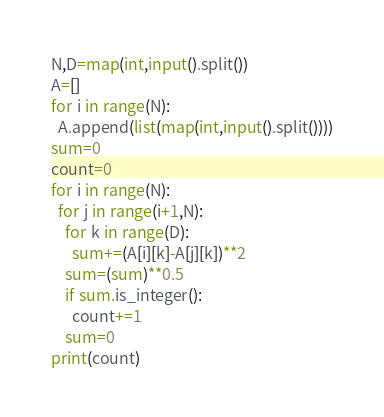<code> <loc_0><loc_0><loc_500><loc_500><_Python_>N,D=map(int,input().split())
A=[]
for i in range(N):
  A.append(list(map(int,input().split())))
sum=0
count=0
for i in range(N):
  for j in range(i+1,N):
    for k in range(D):
      sum+=(A[i][k]-A[j][k])**2
    sum=(sum)**0.5
    if sum.is_integer():
      count+=1
    sum=0
print(count)</code> 